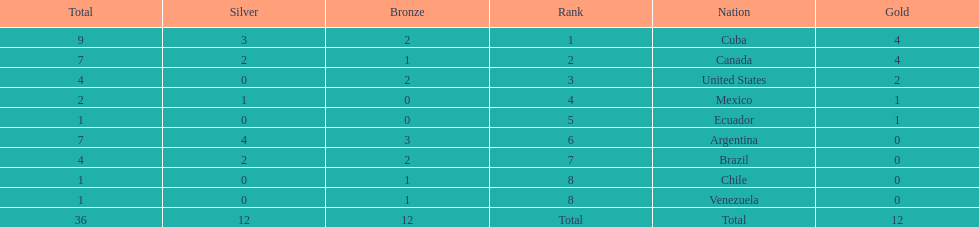Who is ranked #1? Cuba. 